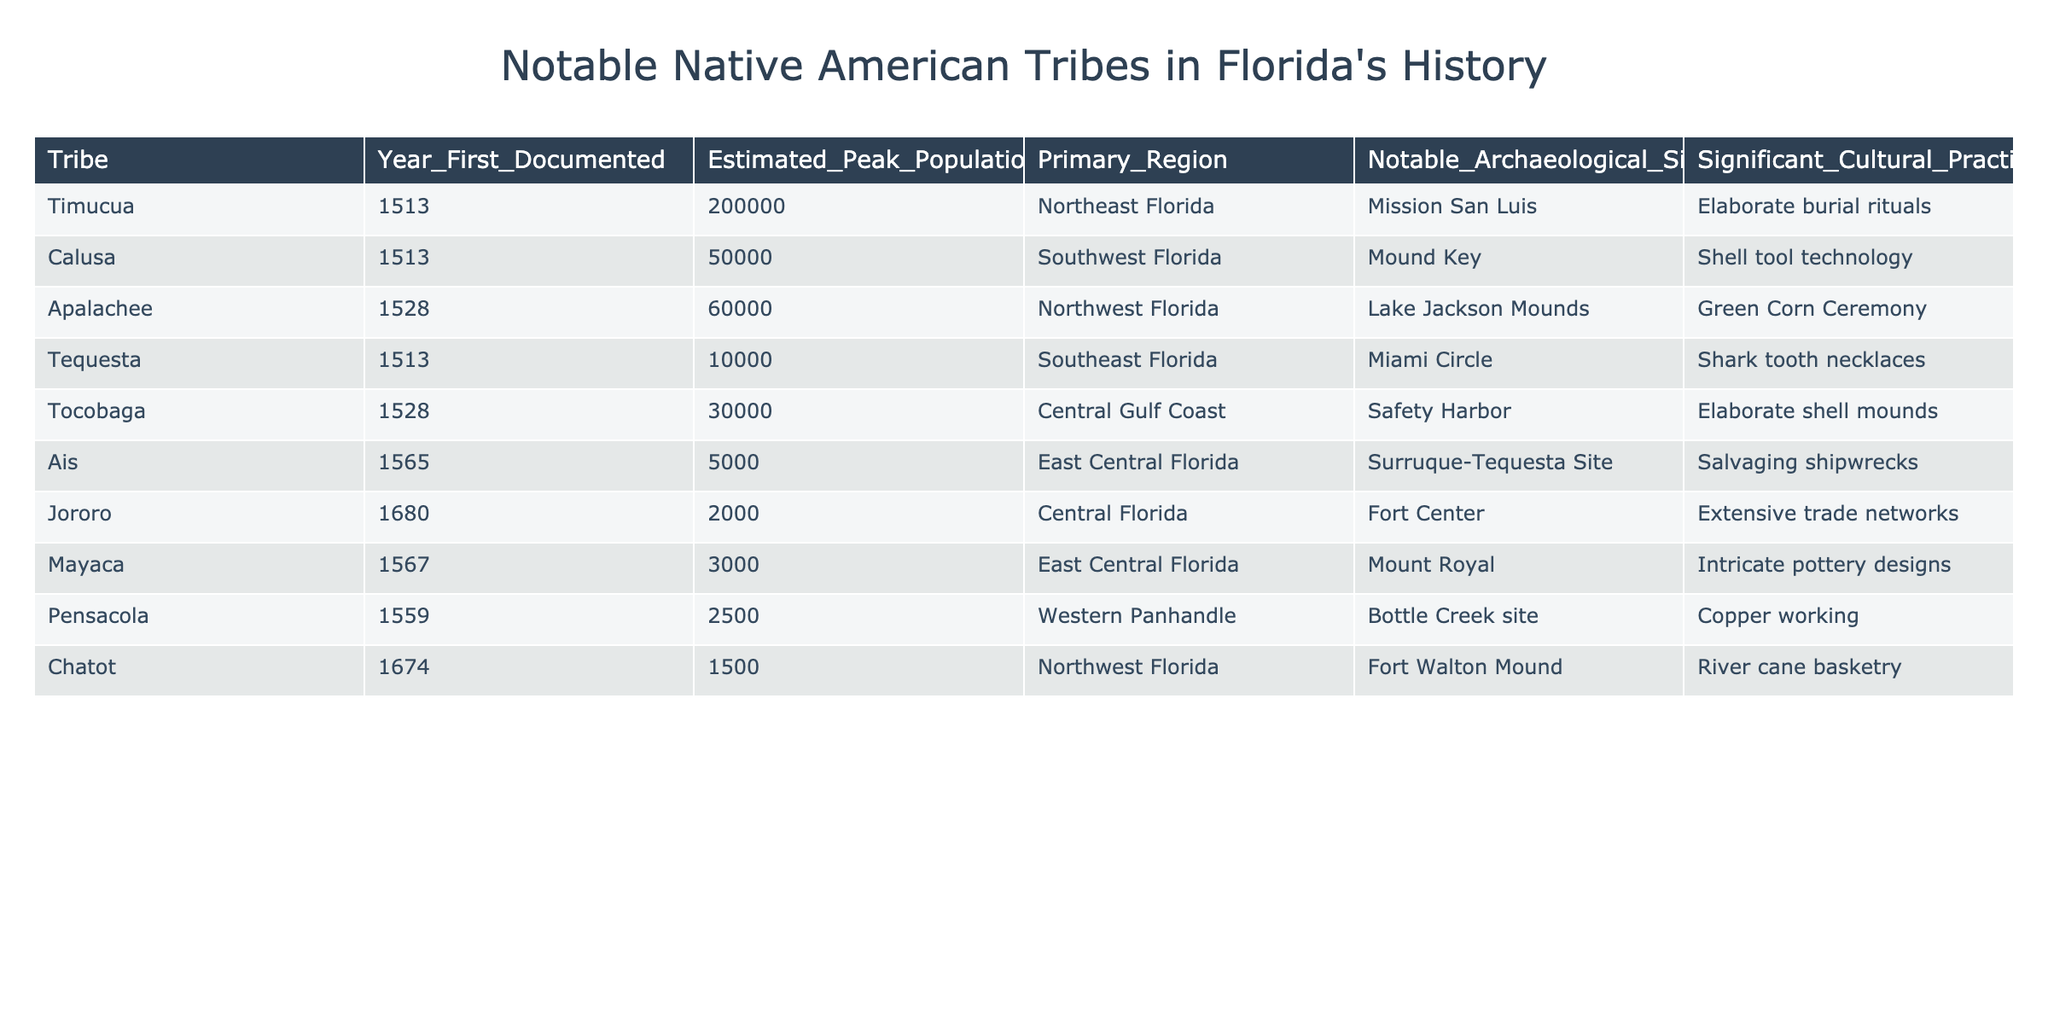What is the primary region of the Timucua tribe? The table lists the Timucua tribe and indicates that their primary region is Northeast Florida.
Answer: Northeast Florida What year was the Ais tribe first documented? According to the table, the Ais tribe was first documented in the year 1565.
Answer: 1565 Which tribe had the highest estimated peak population? The table shows that the Timucua tribe had the highest estimated peak population of 200,000.
Answer: Timucua How many tribes are listed in total in the table? The table provides data for 8 different tribes detailed in the entries.
Answer: 8 What significant cultural practice is associated with the Calusa tribe? The table states that the significant cultural practice associated with the Calusa tribe is shell tool technology.
Answer: Shell tool technology What is the average estimated peak population of the tribes listed? To find the average, we sum the estimated peak populations (200000 + 50000 + 60000 + 10000 + 30000 + 5000 + 2000 + 3000 + 2500 + 1500 = 307000) and divide by the number of tribes (8). Therefore, the average is 307000/8 = 38375.
Answer: 38375 Is it true that the Tequesta tribe is associated with shark tooth necklaces? The table indicates that the Tequesta tribe is indeed noted for their practice of creating shark tooth necklaces.
Answer: Yes Which tribe is associated with elaborate burial rituals and what is their estimated peak population? Referring to the table, the Timucua tribe is associated with elaborate burial rituals and their estimated peak population is 200,000.
Answer: Timucua, 200000 Which tribe had the smallest estimated peak population and what was it? The table shows that the Chatot tribe had the smallest estimated peak population of 1500.
Answer: Chatot, 1500 What notable archaeological site is associated with the Apalachee tribe? According to the table, the notable archaeological site associated with the Apalachee tribe is the Lake Jackson Mounds.
Answer: Lake Jackson Mounds 